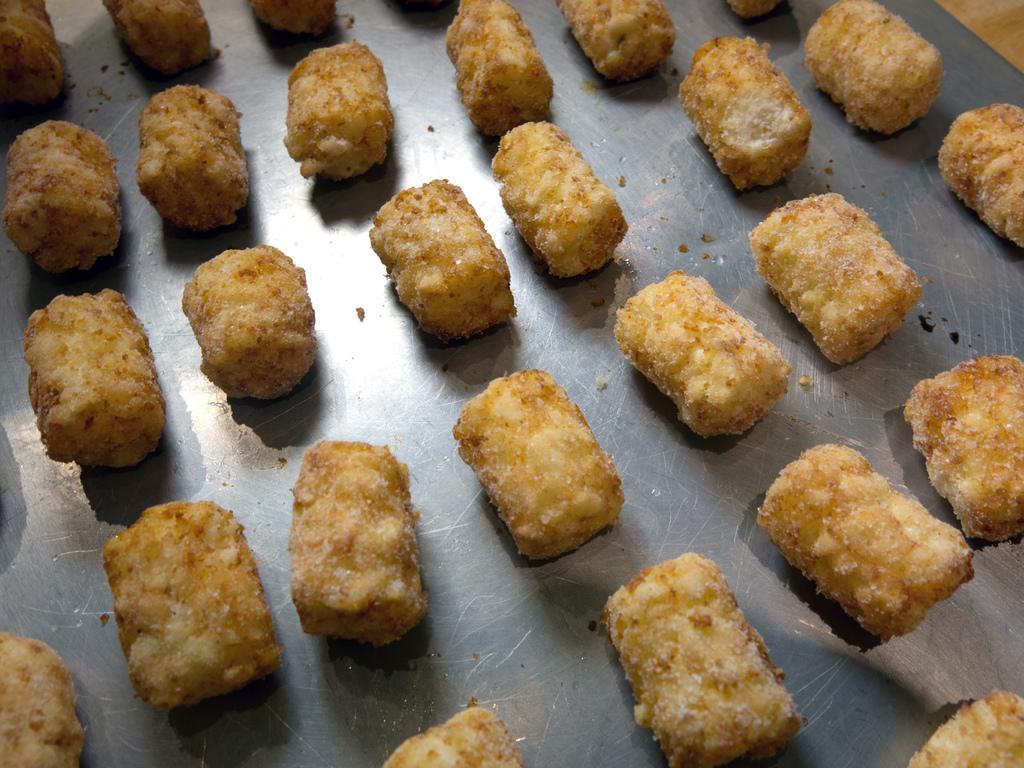Can you describe this image briefly? This image consists of some eatables. They are placed in the tray. 